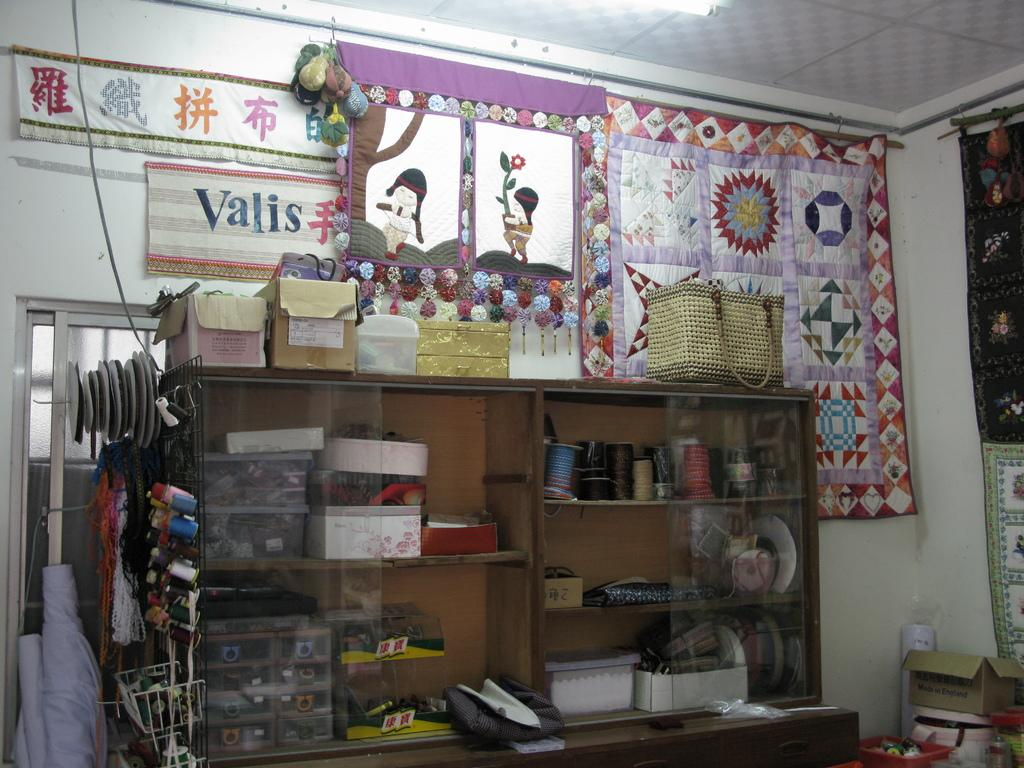Provide a one-sentence caption for the provided image. The interior of a sewing shop has a sign that says Valis. 